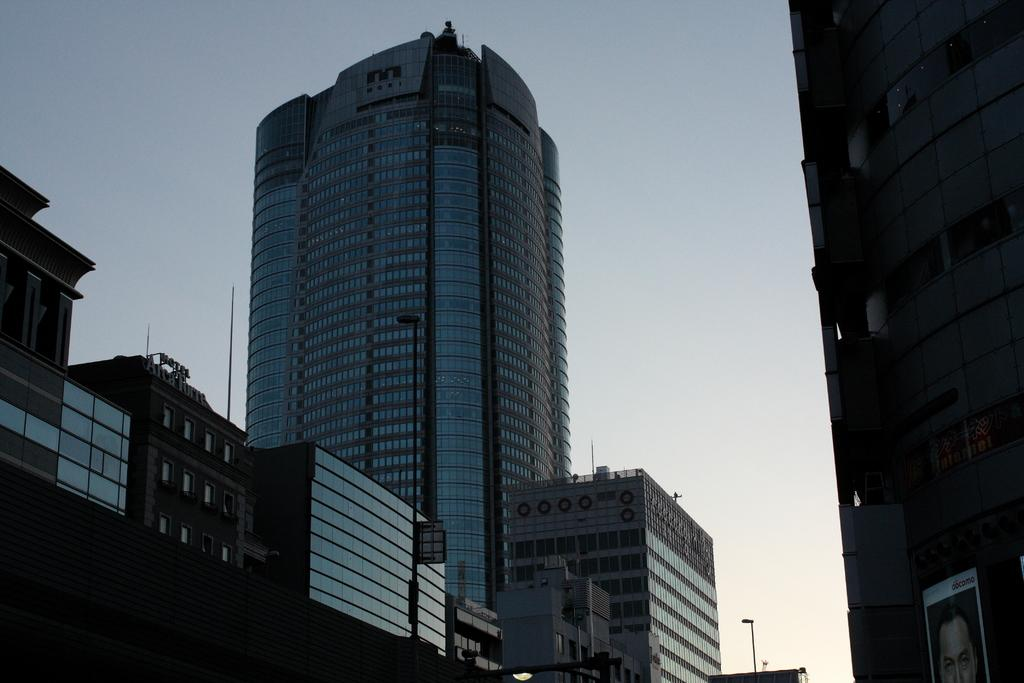What type of building is the main subject of the image? There is a skyscraper in the image. What feature do the buildings in the image have? The buildings have glass doors. What can be seen at the top of the skyscraper? There is a name board at the top of the building. What else is present in the image besides the buildings? There is a poster and streetlights visible in the image. How do the cows react to the cherry in the image? There are no cows or cherries present in the image. 